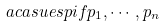<formula> <loc_0><loc_0><loc_500><loc_500>a c a s u e s p { i f } p _ { 1 } , \cdots , p _ { n }</formula> 